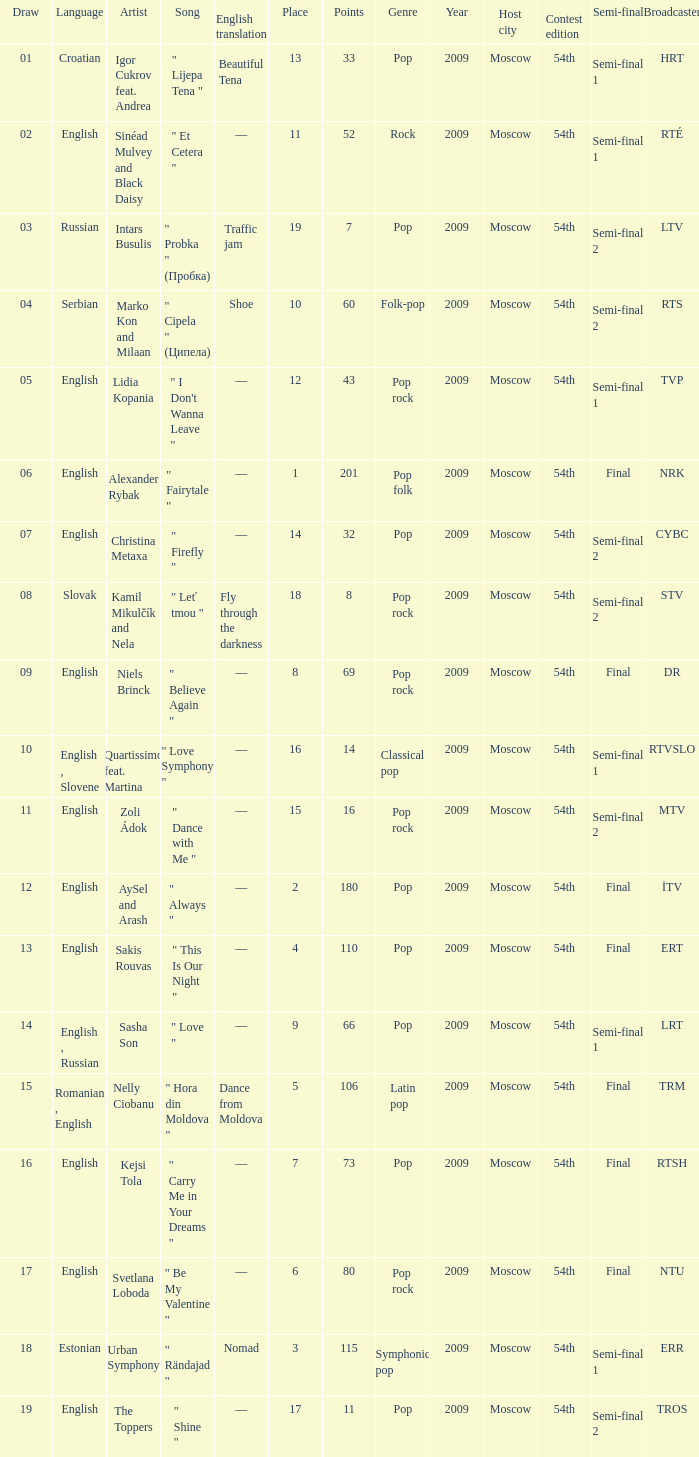What is the average Points when the artist is kamil mikulčík and nela, and the Place is larger than 18? None. 